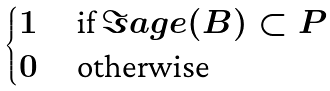Convert formula to latex. <formula><loc_0><loc_0><loc_500><loc_500>\begin{cases} 1 & \text { if } \Im a g e ( B ) \subset P \\ 0 & \text { otherwise } \end{cases}</formula> 